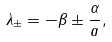<formula> <loc_0><loc_0><loc_500><loc_500>\lambda _ { \pm } = - \beta \pm \frac { \alpha } { a } ,</formula> 